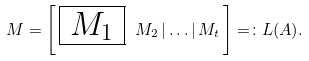Convert formula to latex. <formula><loc_0><loc_0><loc_500><loc_500>M = \left [ \, \boxed { \, M _ { 1 } \, } \ M _ { 2 } \, | \dots | \, M _ { t } \, \right ] = \colon L ( A ) .</formula> 